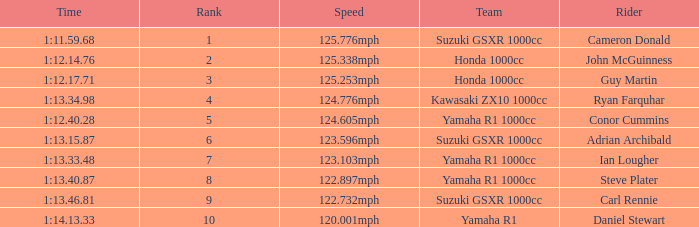What time did team kawasaki zx10 1000cc have? 1:13.34.98. 